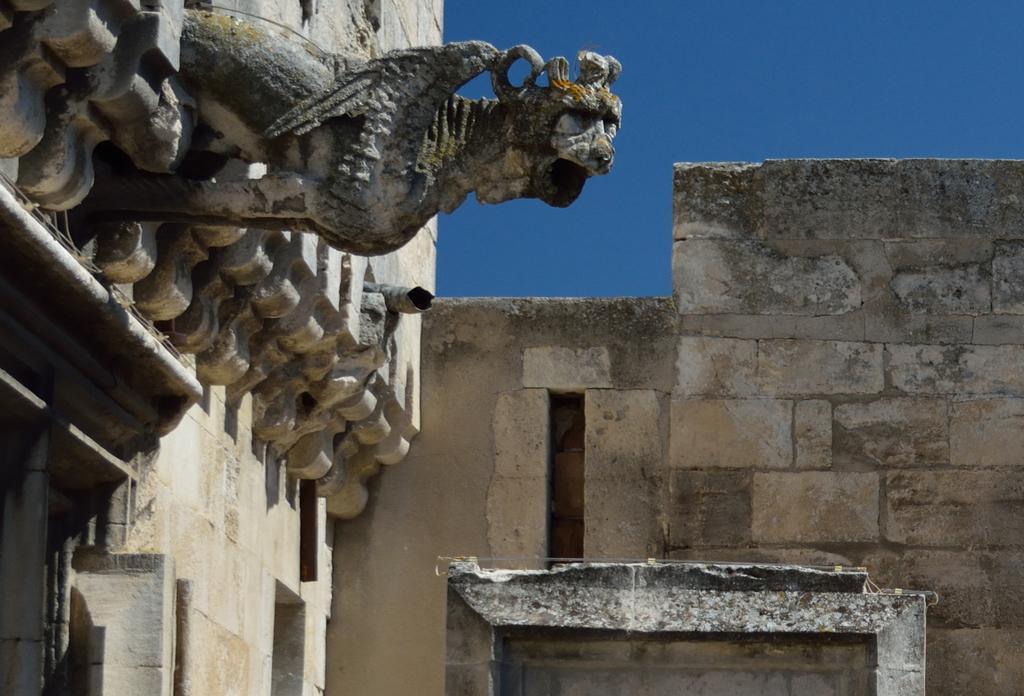How would you summarize this image in a sentence or two? It is the sculpture on this wall, on the right side it is the stone wall. At the top there is the sky in blue color. 